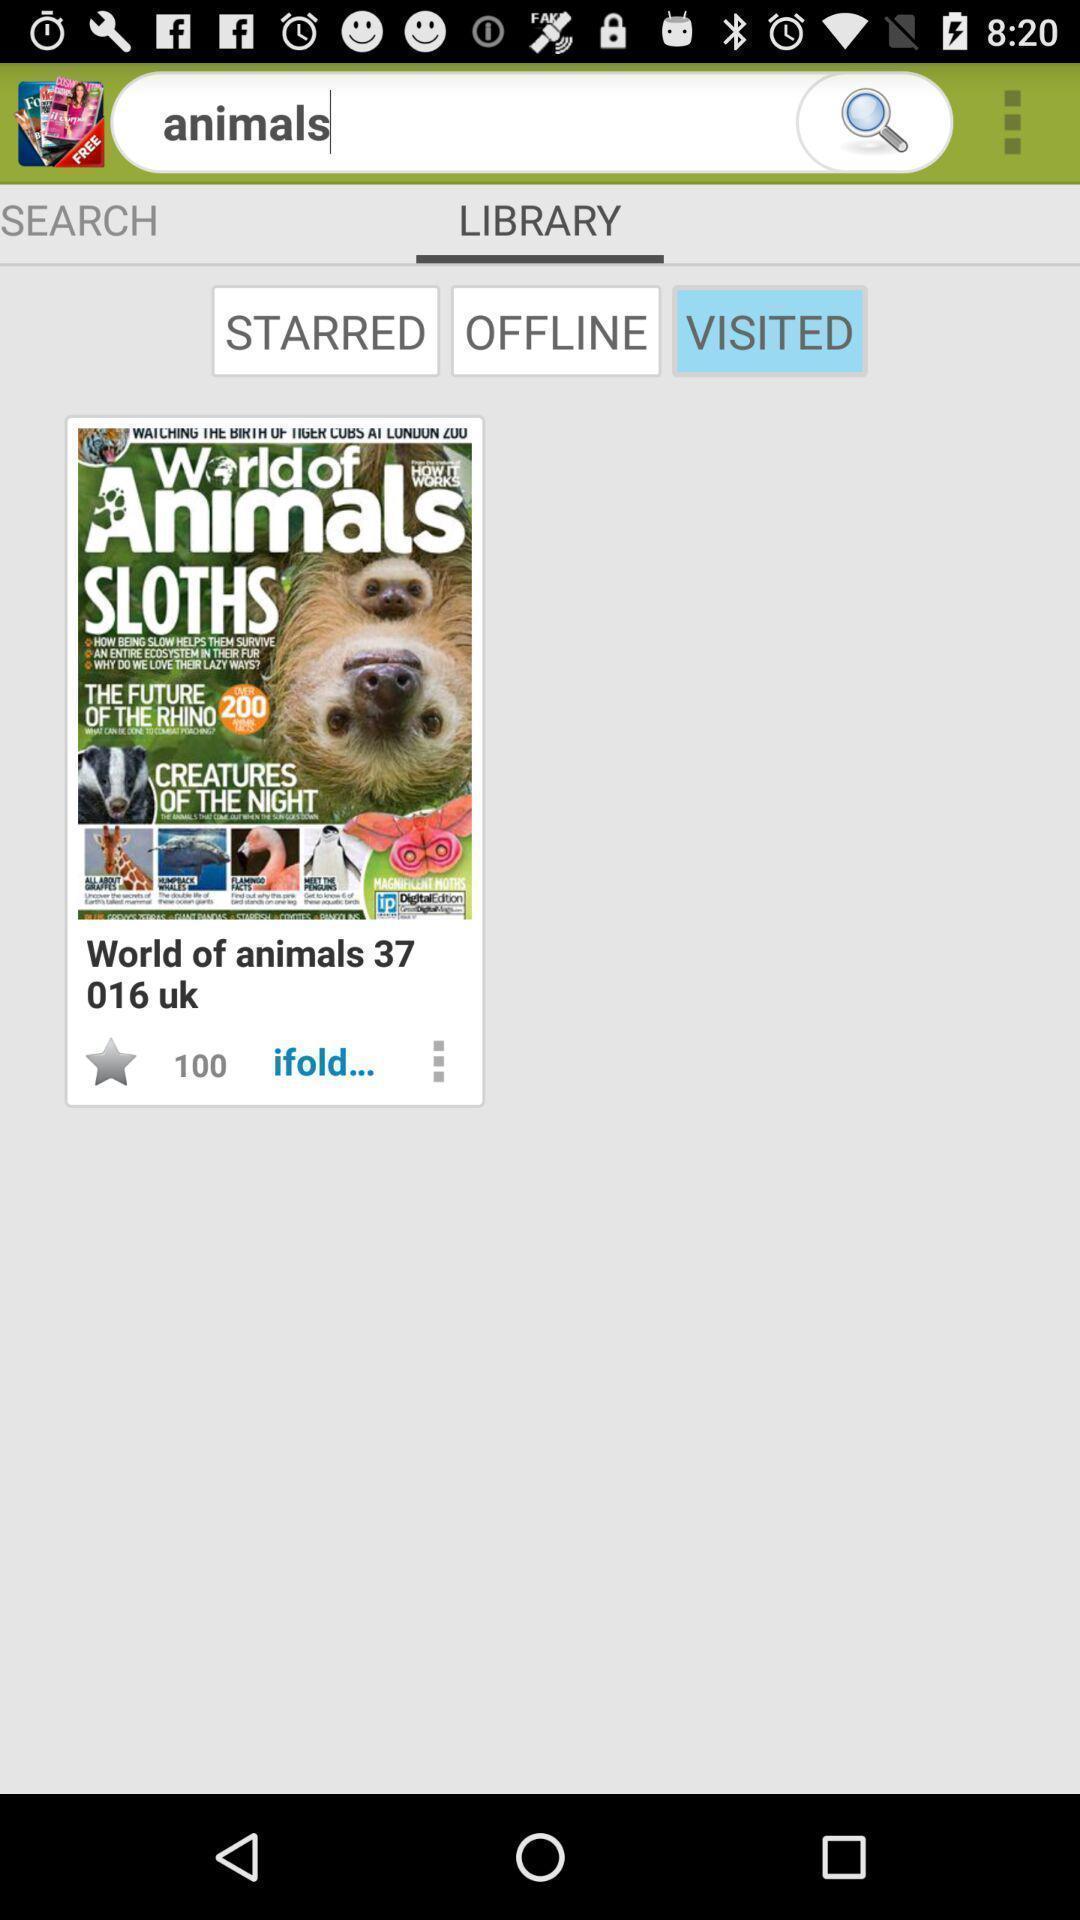Describe the visual elements of this screenshot. Search page to find animals. 